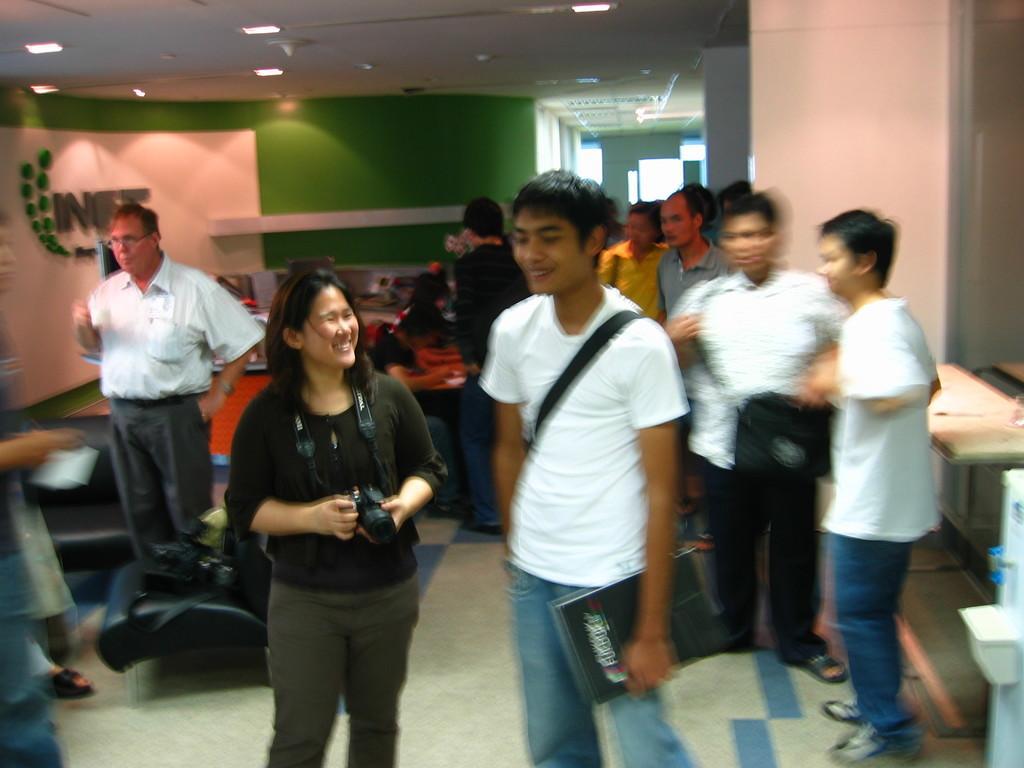Could you give a brief overview of what you see in this image? There is a girl holding a camera and a boy holding a book in the foreground, there is a water dispenser on the right side. There are other people, chair, window, text and the lamps in the background. 